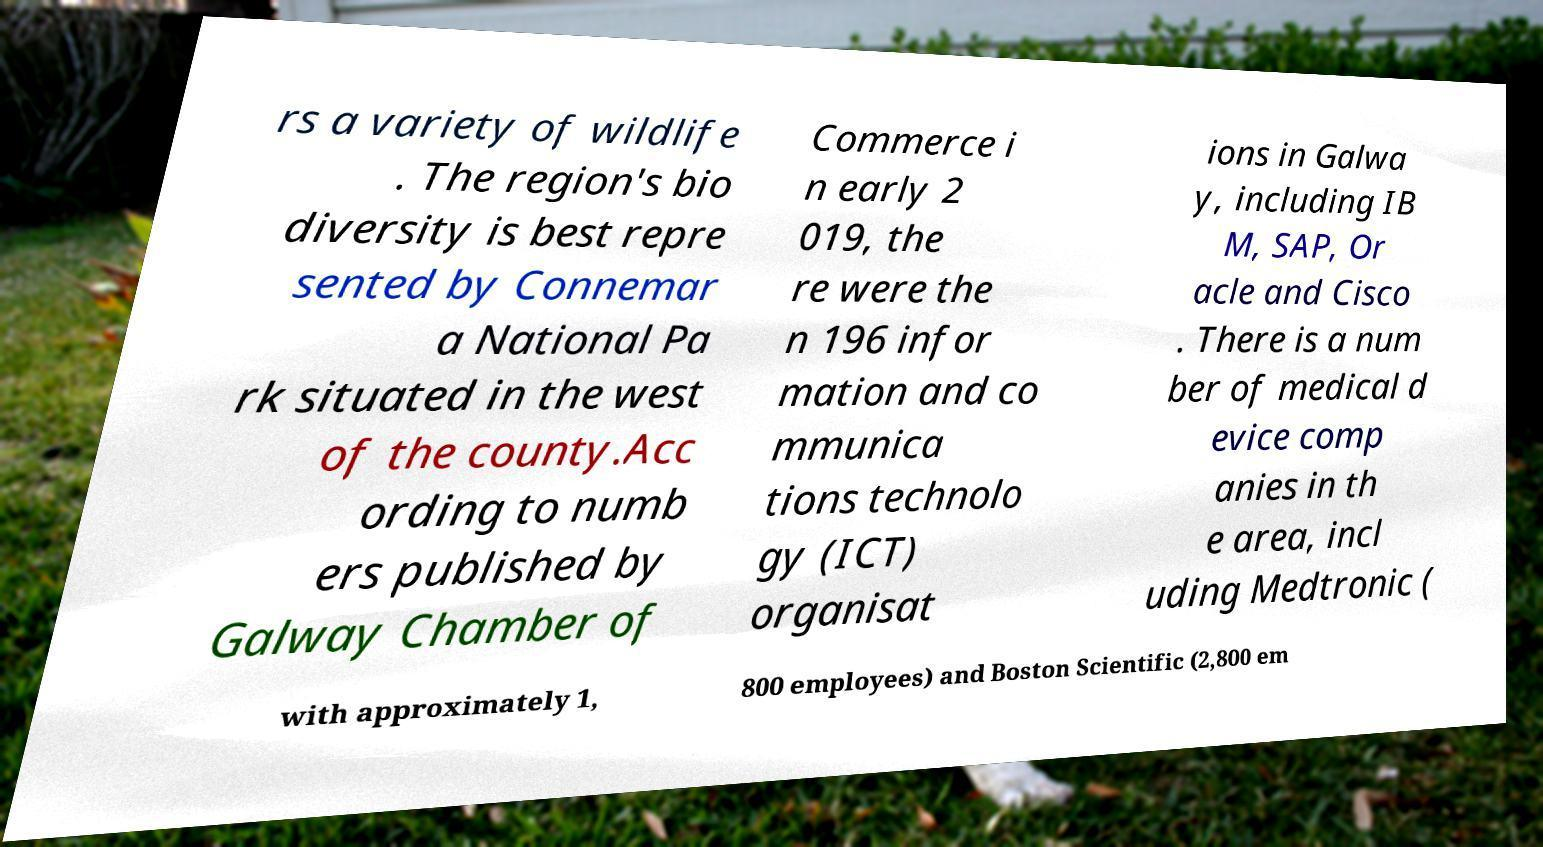Can you read and provide the text displayed in the image?This photo seems to have some interesting text. Can you extract and type it out for me? rs a variety of wildlife . The region's bio diversity is best repre sented by Connemar a National Pa rk situated in the west of the county.Acc ording to numb ers published by Galway Chamber of Commerce i n early 2 019, the re were the n 196 infor mation and co mmunica tions technolo gy (ICT) organisat ions in Galwa y, including IB M, SAP, Or acle and Cisco . There is a num ber of medical d evice comp anies in th e area, incl uding Medtronic ( with approximately 1, 800 employees) and Boston Scientific (2,800 em 